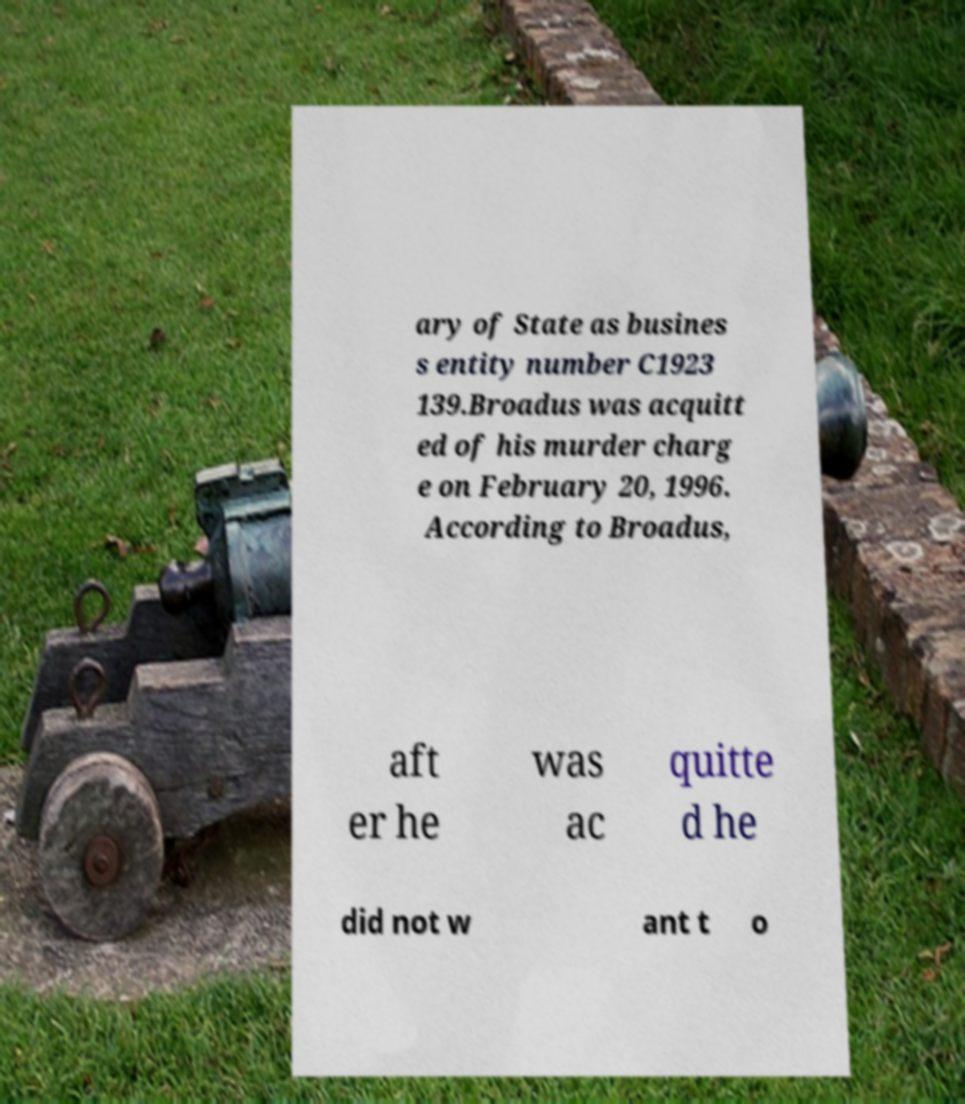Could you extract and type out the text from this image? ary of State as busines s entity number C1923 139.Broadus was acquitt ed of his murder charg e on February 20, 1996. According to Broadus, aft er he was ac quitte d he did not w ant t o 